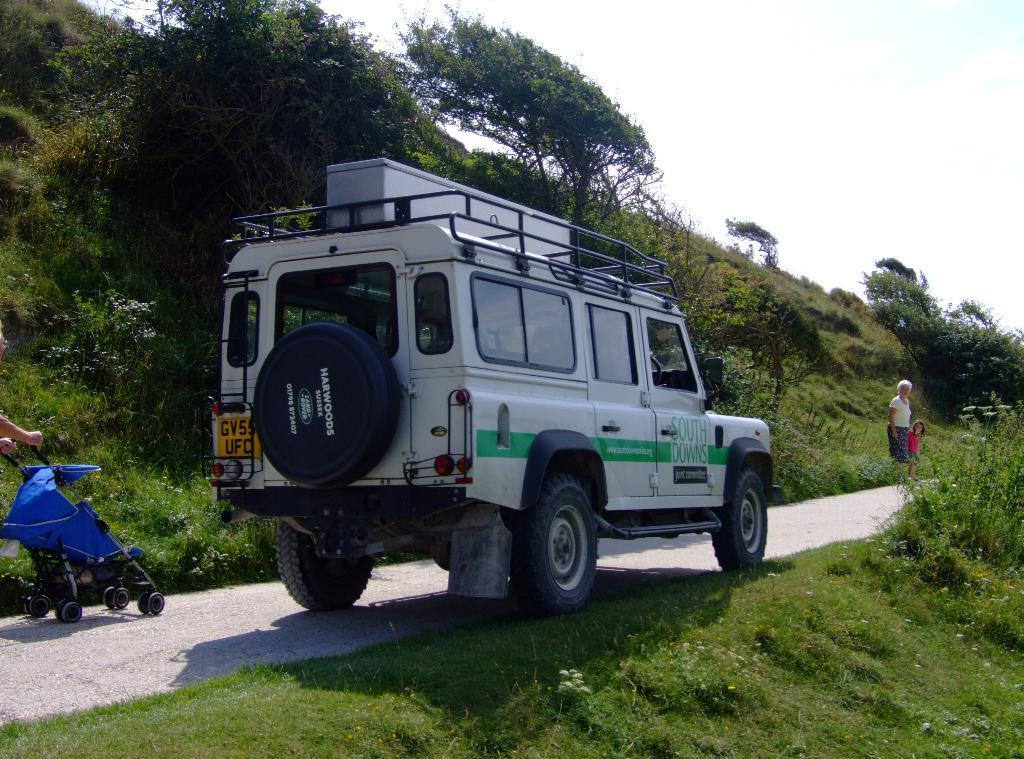Please provide a concise description of this image. In this image there is a baby trolley, a car and two people walking on the road, besides the road there is grass on the surface and trees. 